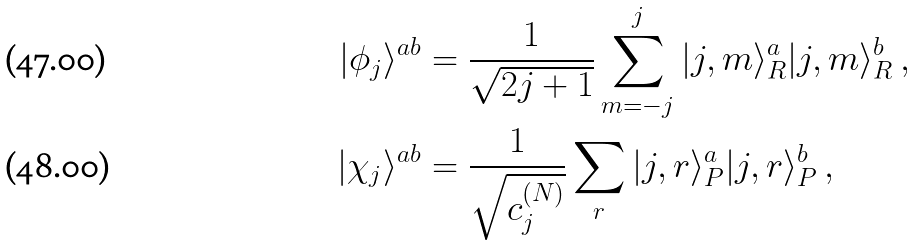Convert formula to latex. <formula><loc_0><loc_0><loc_500><loc_500>| \phi _ { j } \rangle ^ { a b } & = \frac { 1 } { \sqrt { 2 j + 1 } } \sum _ { m = - j } ^ { j } | j , m \rangle _ { R } ^ { a } | j , m \rangle _ { R } ^ { b } \, , \\ | \chi _ { j } \rangle ^ { a b } & = \frac { 1 } { \sqrt { c _ { j } ^ { ( N ) } } } \sum _ { r } | j , r \rangle _ { P } ^ { a } | j , r \rangle _ { P } ^ { b } \, ,</formula> 